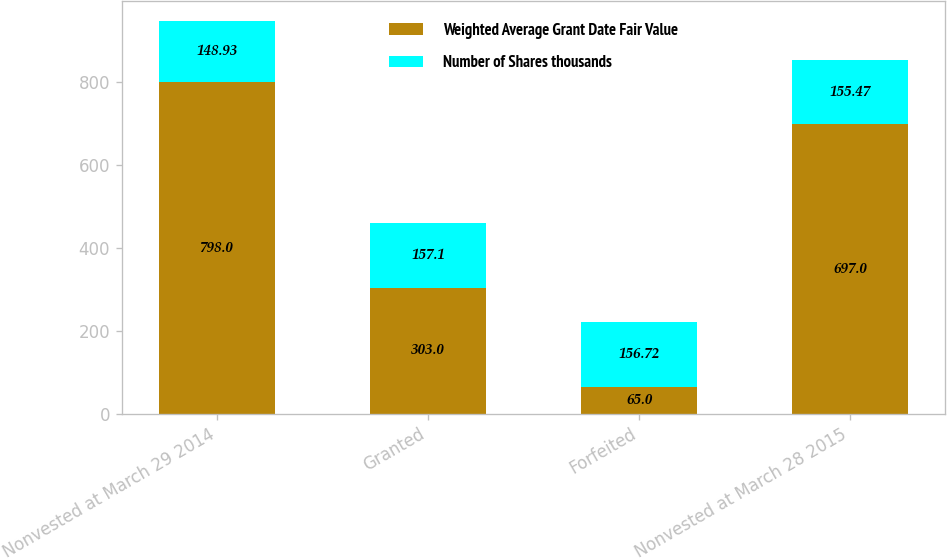Convert chart. <chart><loc_0><loc_0><loc_500><loc_500><stacked_bar_chart><ecel><fcel>Nonvested at March 29 2014<fcel>Granted<fcel>Forfeited<fcel>Nonvested at March 28 2015<nl><fcel>Weighted Average Grant Date Fair Value<fcel>798<fcel>303<fcel>65<fcel>697<nl><fcel>Number of Shares thousands<fcel>148.93<fcel>157.1<fcel>156.72<fcel>155.47<nl></chart> 